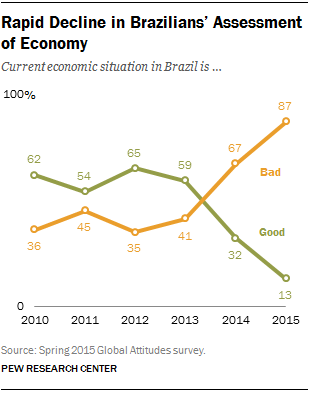Draw attention to some important aspects in this diagram. There is one intercepting point. In 2015, there were particularly divergent opinions about Brazil's economy. 